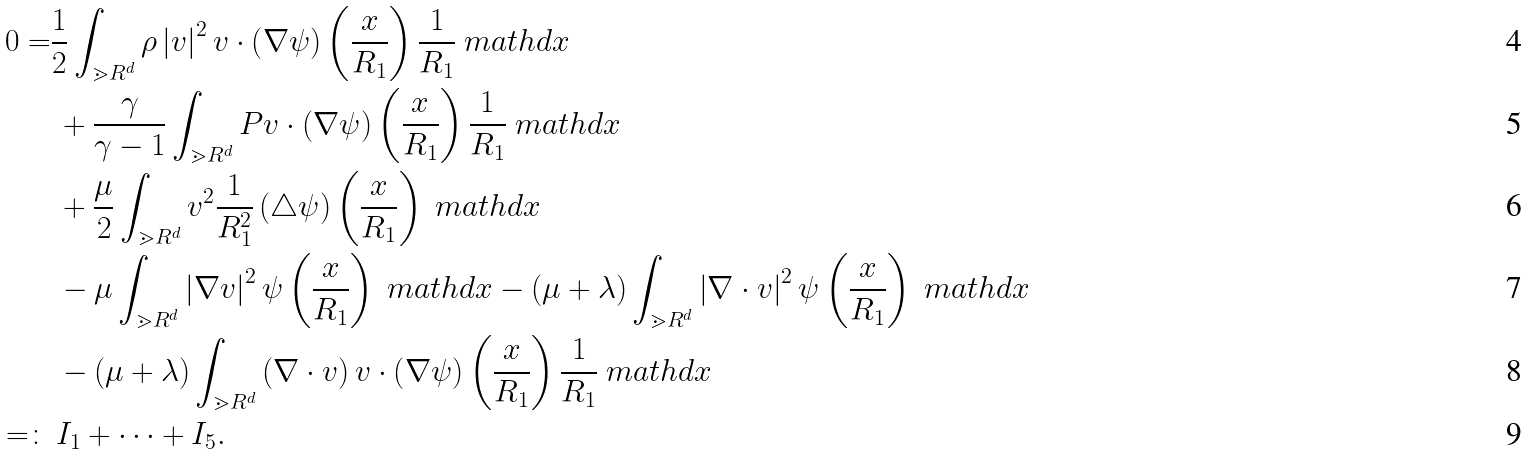Convert formula to latex. <formula><loc_0><loc_0><loc_500><loc_500>0 = & \frac { 1 } { 2 } \int _ { \mathbb { m } { R } ^ { d } } \rho \left | v \right | ^ { 2 } v \cdot \left ( \nabla \psi \right ) \left ( \frac { x } { R _ { 1 } } \right ) \frac { 1 } { R _ { 1 } } \ m a t h d x \\ & \, + \frac { \gamma } { \gamma - 1 } \int _ { \mathbb { m } { R } ^ { d } } P v \cdot \left ( \nabla \psi \right ) \left ( \frac { x } { R _ { 1 } } \right ) \frac { 1 } { R _ { 1 } } \ m a t h d x \\ & \, + \frac { \mu } { 2 } \int _ { \mathbb { m } { R } ^ { d } } v ^ { 2 } \frac { 1 } { R _ { 1 } ^ { 2 } } \left ( \triangle \psi \right ) \left ( \frac { x } { R _ { 1 } } \right ) \ m a t h d x \\ & \, - \mu \int _ { \mathbb { m } { R } ^ { d } } \left | \nabla v \right | ^ { 2 } \psi \left ( \frac { x } { R _ { 1 } } \right ) \ m a t h d x - \left ( \mu + \lambda \right ) \int _ { \mathbb { m } { R } ^ { d } } \left | \nabla \cdot v \right | ^ { 2 } \psi \left ( \frac { x } { R _ { 1 } } \right ) \ m a t h d x \\ & \, - \left ( \mu + \lambda \right ) \int _ { \mathbb { m } { R } ^ { d } } \left ( \nabla \cdot v \right ) v \cdot \left ( \nabla \psi \right ) \left ( \frac { x } { R _ { 1 } } \right ) \frac { 1 } { R _ { 1 } } \ m a t h d x \\ = \colon & \, I _ { 1 } + \cdots + I _ { 5 } .</formula> 